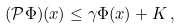Convert formula to latex. <formula><loc_0><loc_0><loc_500><loc_500>( \mathcal { P } \Phi ) ( x ) \leq \gamma \Phi ( x ) + K \, ,</formula> 